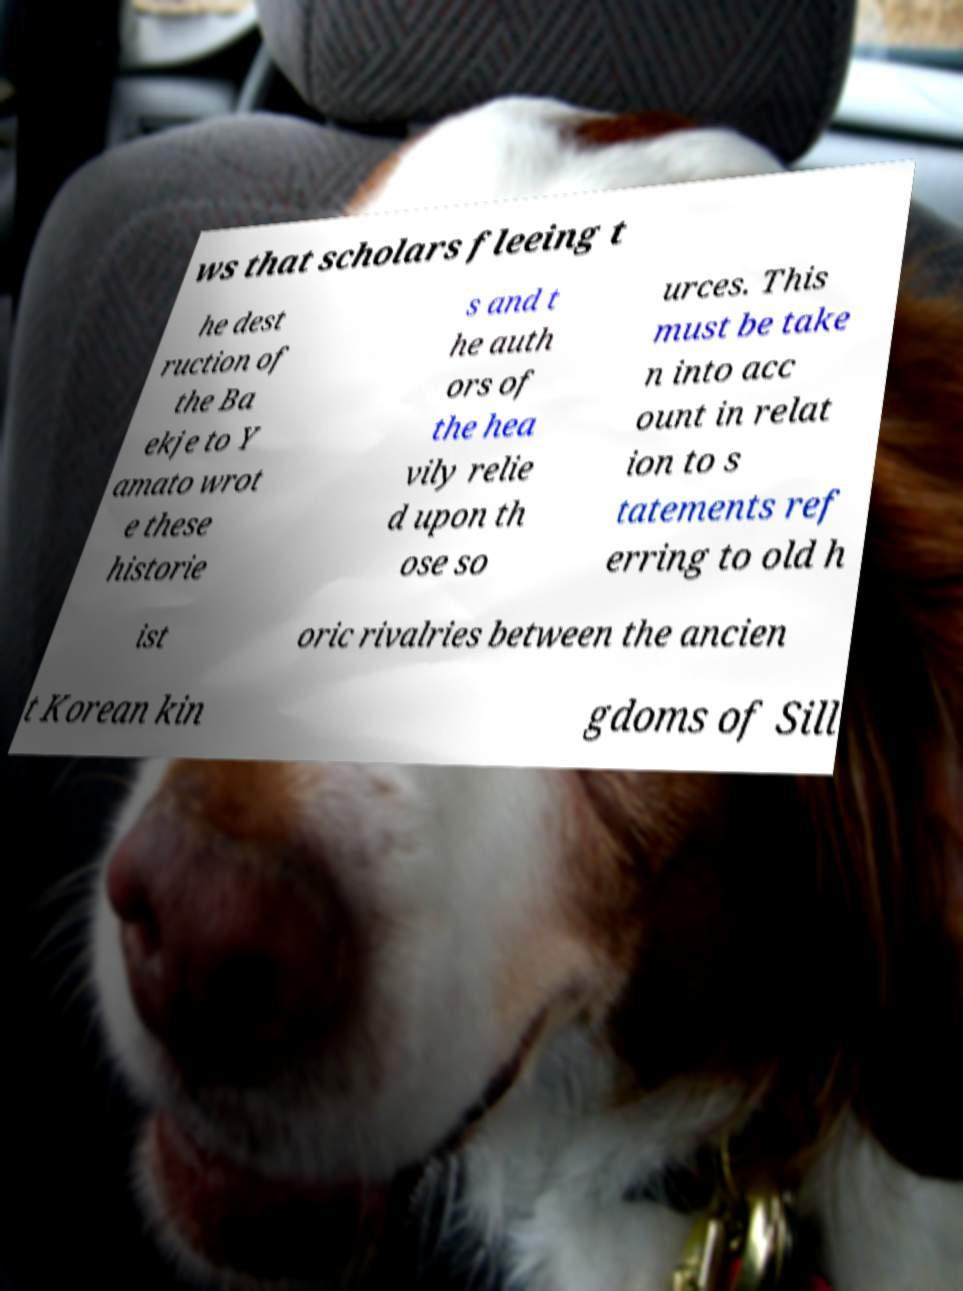Can you read and provide the text displayed in the image?This photo seems to have some interesting text. Can you extract and type it out for me? ws that scholars fleeing t he dest ruction of the Ba ekje to Y amato wrot e these historie s and t he auth ors of the hea vily relie d upon th ose so urces. This must be take n into acc ount in relat ion to s tatements ref erring to old h ist oric rivalries between the ancien t Korean kin gdoms of Sill 